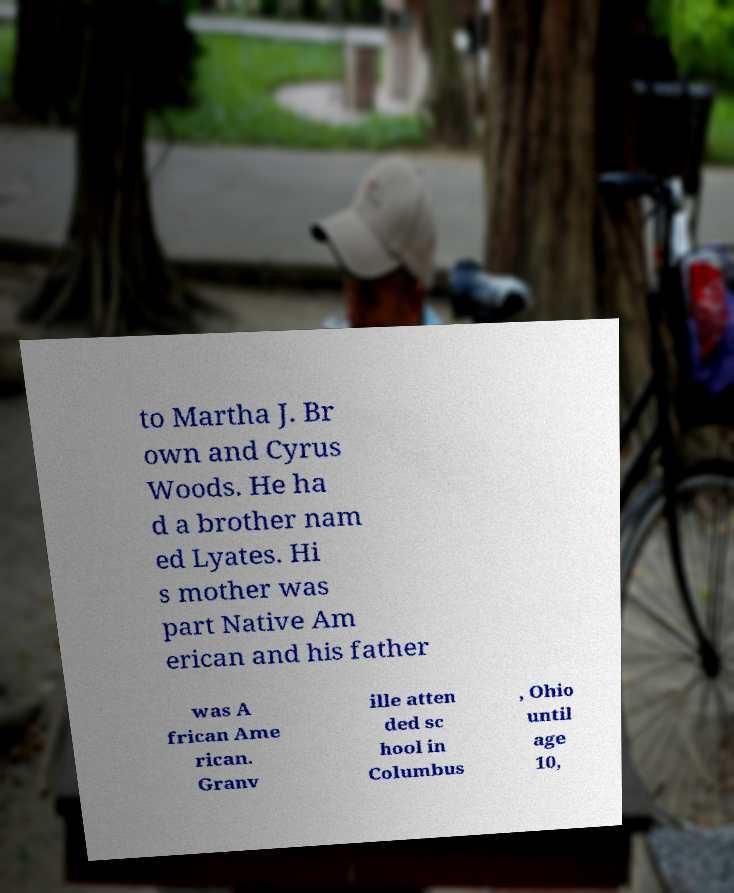Could you extract and type out the text from this image? to Martha J. Br own and Cyrus Woods. He ha d a brother nam ed Lyates. Hi s mother was part Native Am erican and his father was A frican Ame rican. Granv ille atten ded sc hool in Columbus , Ohio until age 10, 